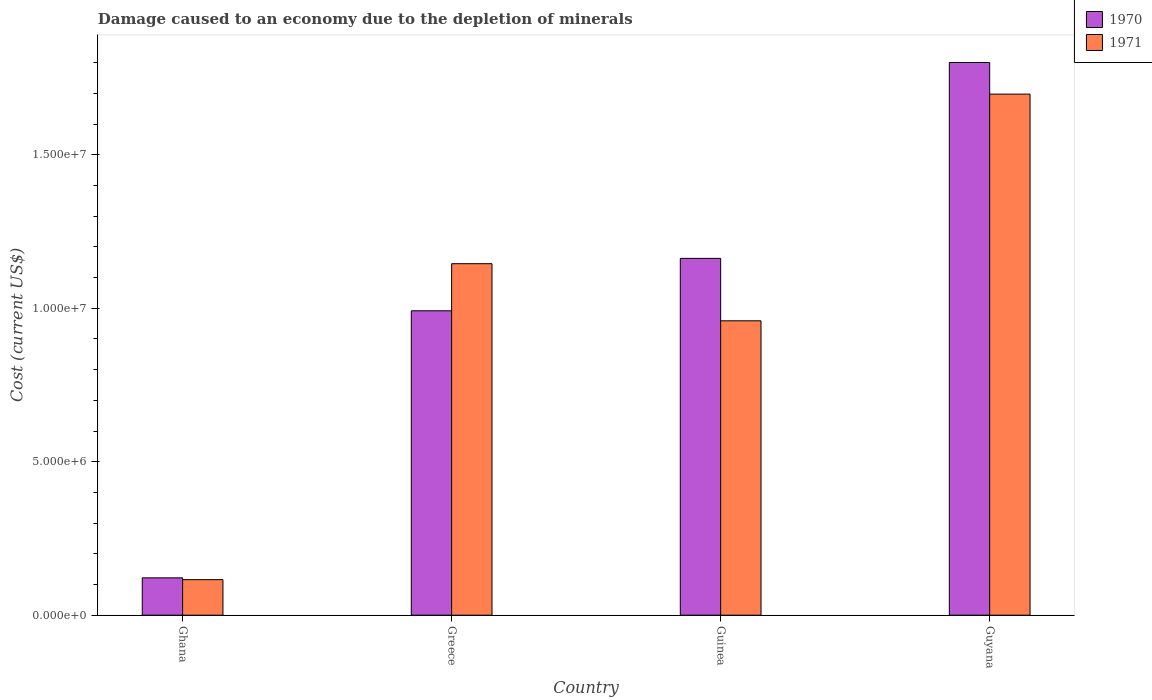How many different coloured bars are there?
Your response must be concise. 2. Are the number of bars per tick equal to the number of legend labels?
Offer a very short reply. Yes. How many bars are there on the 4th tick from the right?
Provide a short and direct response. 2. What is the label of the 3rd group of bars from the left?
Ensure brevity in your answer.  Guinea. What is the cost of damage caused due to the depletion of minerals in 1971 in Greece?
Your answer should be very brief. 1.15e+07. Across all countries, what is the maximum cost of damage caused due to the depletion of minerals in 1970?
Offer a terse response. 1.80e+07. Across all countries, what is the minimum cost of damage caused due to the depletion of minerals in 1971?
Ensure brevity in your answer.  1.16e+06. In which country was the cost of damage caused due to the depletion of minerals in 1970 maximum?
Give a very brief answer. Guyana. In which country was the cost of damage caused due to the depletion of minerals in 1970 minimum?
Keep it short and to the point. Ghana. What is the total cost of damage caused due to the depletion of minerals in 1970 in the graph?
Offer a terse response. 4.08e+07. What is the difference between the cost of damage caused due to the depletion of minerals in 1971 in Greece and that in Guyana?
Keep it short and to the point. -5.52e+06. What is the difference between the cost of damage caused due to the depletion of minerals in 1971 in Guinea and the cost of damage caused due to the depletion of minerals in 1970 in Ghana?
Keep it short and to the point. 8.37e+06. What is the average cost of damage caused due to the depletion of minerals in 1971 per country?
Keep it short and to the point. 9.79e+06. What is the difference between the cost of damage caused due to the depletion of minerals of/in 1970 and cost of damage caused due to the depletion of minerals of/in 1971 in Guinea?
Offer a very short reply. 2.03e+06. In how many countries, is the cost of damage caused due to the depletion of minerals in 1971 greater than 1000000 US$?
Give a very brief answer. 4. What is the ratio of the cost of damage caused due to the depletion of minerals in 1971 in Ghana to that in Guyana?
Make the answer very short. 0.07. Is the cost of damage caused due to the depletion of minerals in 1971 in Ghana less than that in Guyana?
Offer a very short reply. Yes. Is the difference between the cost of damage caused due to the depletion of minerals in 1970 in Guinea and Guyana greater than the difference between the cost of damage caused due to the depletion of minerals in 1971 in Guinea and Guyana?
Your response must be concise. Yes. What is the difference between the highest and the second highest cost of damage caused due to the depletion of minerals in 1971?
Give a very brief answer. 5.52e+06. What is the difference between the highest and the lowest cost of damage caused due to the depletion of minerals in 1971?
Give a very brief answer. 1.58e+07. Is the sum of the cost of damage caused due to the depletion of minerals in 1970 in Ghana and Greece greater than the maximum cost of damage caused due to the depletion of minerals in 1971 across all countries?
Your answer should be very brief. No. What does the 1st bar from the left in Ghana represents?
Give a very brief answer. 1970. Are all the bars in the graph horizontal?
Offer a very short reply. No. What is the difference between two consecutive major ticks on the Y-axis?
Your answer should be compact. 5.00e+06. Does the graph contain any zero values?
Keep it short and to the point. No. Where does the legend appear in the graph?
Your answer should be very brief. Top right. How are the legend labels stacked?
Ensure brevity in your answer.  Vertical. What is the title of the graph?
Provide a succinct answer. Damage caused to an economy due to the depletion of minerals. Does "1974" appear as one of the legend labels in the graph?
Your answer should be compact. No. What is the label or title of the Y-axis?
Offer a very short reply. Cost (current US$). What is the Cost (current US$) of 1970 in Ghana?
Your response must be concise. 1.22e+06. What is the Cost (current US$) of 1971 in Ghana?
Your response must be concise. 1.16e+06. What is the Cost (current US$) of 1970 in Greece?
Make the answer very short. 9.92e+06. What is the Cost (current US$) of 1971 in Greece?
Offer a terse response. 1.15e+07. What is the Cost (current US$) of 1970 in Guinea?
Keep it short and to the point. 1.16e+07. What is the Cost (current US$) in 1971 in Guinea?
Provide a short and direct response. 9.59e+06. What is the Cost (current US$) in 1970 in Guyana?
Offer a very short reply. 1.80e+07. What is the Cost (current US$) of 1971 in Guyana?
Give a very brief answer. 1.70e+07. Across all countries, what is the maximum Cost (current US$) of 1970?
Offer a terse response. 1.80e+07. Across all countries, what is the maximum Cost (current US$) in 1971?
Offer a very short reply. 1.70e+07. Across all countries, what is the minimum Cost (current US$) in 1970?
Make the answer very short. 1.22e+06. Across all countries, what is the minimum Cost (current US$) in 1971?
Provide a succinct answer. 1.16e+06. What is the total Cost (current US$) in 1970 in the graph?
Your response must be concise. 4.08e+07. What is the total Cost (current US$) in 1971 in the graph?
Offer a terse response. 3.92e+07. What is the difference between the Cost (current US$) in 1970 in Ghana and that in Greece?
Offer a very short reply. -8.70e+06. What is the difference between the Cost (current US$) of 1971 in Ghana and that in Greece?
Provide a succinct answer. -1.03e+07. What is the difference between the Cost (current US$) of 1970 in Ghana and that in Guinea?
Make the answer very short. -1.04e+07. What is the difference between the Cost (current US$) of 1971 in Ghana and that in Guinea?
Your answer should be very brief. -8.43e+06. What is the difference between the Cost (current US$) of 1970 in Ghana and that in Guyana?
Ensure brevity in your answer.  -1.68e+07. What is the difference between the Cost (current US$) in 1971 in Ghana and that in Guyana?
Provide a short and direct response. -1.58e+07. What is the difference between the Cost (current US$) of 1970 in Greece and that in Guinea?
Keep it short and to the point. -1.71e+06. What is the difference between the Cost (current US$) of 1971 in Greece and that in Guinea?
Ensure brevity in your answer.  1.86e+06. What is the difference between the Cost (current US$) of 1970 in Greece and that in Guyana?
Your answer should be very brief. -8.09e+06. What is the difference between the Cost (current US$) of 1971 in Greece and that in Guyana?
Provide a succinct answer. -5.52e+06. What is the difference between the Cost (current US$) in 1970 in Guinea and that in Guyana?
Make the answer very short. -6.38e+06. What is the difference between the Cost (current US$) in 1971 in Guinea and that in Guyana?
Make the answer very short. -7.38e+06. What is the difference between the Cost (current US$) in 1970 in Ghana and the Cost (current US$) in 1971 in Greece?
Ensure brevity in your answer.  -1.02e+07. What is the difference between the Cost (current US$) of 1970 in Ghana and the Cost (current US$) of 1971 in Guinea?
Provide a succinct answer. -8.37e+06. What is the difference between the Cost (current US$) of 1970 in Ghana and the Cost (current US$) of 1971 in Guyana?
Your answer should be compact. -1.58e+07. What is the difference between the Cost (current US$) of 1970 in Greece and the Cost (current US$) of 1971 in Guinea?
Your answer should be very brief. 3.26e+05. What is the difference between the Cost (current US$) in 1970 in Greece and the Cost (current US$) in 1971 in Guyana?
Ensure brevity in your answer.  -7.06e+06. What is the difference between the Cost (current US$) in 1970 in Guinea and the Cost (current US$) in 1971 in Guyana?
Ensure brevity in your answer.  -5.35e+06. What is the average Cost (current US$) of 1970 per country?
Provide a short and direct response. 1.02e+07. What is the average Cost (current US$) of 1971 per country?
Provide a short and direct response. 9.79e+06. What is the difference between the Cost (current US$) of 1970 and Cost (current US$) of 1971 in Ghana?
Your answer should be very brief. 5.86e+04. What is the difference between the Cost (current US$) in 1970 and Cost (current US$) in 1971 in Greece?
Keep it short and to the point. -1.53e+06. What is the difference between the Cost (current US$) in 1970 and Cost (current US$) in 1971 in Guinea?
Your response must be concise. 2.03e+06. What is the difference between the Cost (current US$) in 1970 and Cost (current US$) in 1971 in Guyana?
Keep it short and to the point. 1.03e+06. What is the ratio of the Cost (current US$) in 1970 in Ghana to that in Greece?
Provide a short and direct response. 0.12. What is the ratio of the Cost (current US$) of 1971 in Ghana to that in Greece?
Offer a very short reply. 0.1. What is the ratio of the Cost (current US$) of 1970 in Ghana to that in Guinea?
Your answer should be compact. 0.1. What is the ratio of the Cost (current US$) of 1971 in Ghana to that in Guinea?
Offer a terse response. 0.12. What is the ratio of the Cost (current US$) in 1970 in Ghana to that in Guyana?
Provide a short and direct response. 0.07. What is the ratio of the Cost (current US$) of 1971 in Ghana to that in Guyana?
Offer a very short reply. 0.07. What is the ratio of the Cost (current US$) in 1970 in Greece to that in Guinea?
Your response must be concise. 0.85. What is the ratio of the Cost (current US$) in 1971 in Greece to that in Guinea?
Make the answer very short. 1.19. What is the ratio of the Cost (current US$) of 1970 in Greece to that in Guyana?
Provide a succinct answer. 0.55. What is the ratio of the Cost (current US$) of 1971 in Greece to that in Guyana?
Ensure brevity in your answer.  0.67. What is the ratio of the Cost (current US$) in 1970 in Guinea to that in Guyana?
Provide a short and direct response. 0.65. What is the ratio of the Cost (current US$) of 1971 in Guinea to that in Guyana?
Offer a terse response. 0.56. What is the difference between the highest and the second highest Cost (current US$) in 1970?
Offer a very short reply. 6.38e+06. What is the difference between the highest and the second highest Cost (current US$) in 1971?
Make the answer very short. 5.52e+06. What is the difference between the highest and the lowest Cost (current US$) in 1970?
Provide a succinct answer. 1.68e+07. What is the difference between the highest and the lowest Cost (current US$) in 1971?
Your answer should be compact. 1.58e+07. 